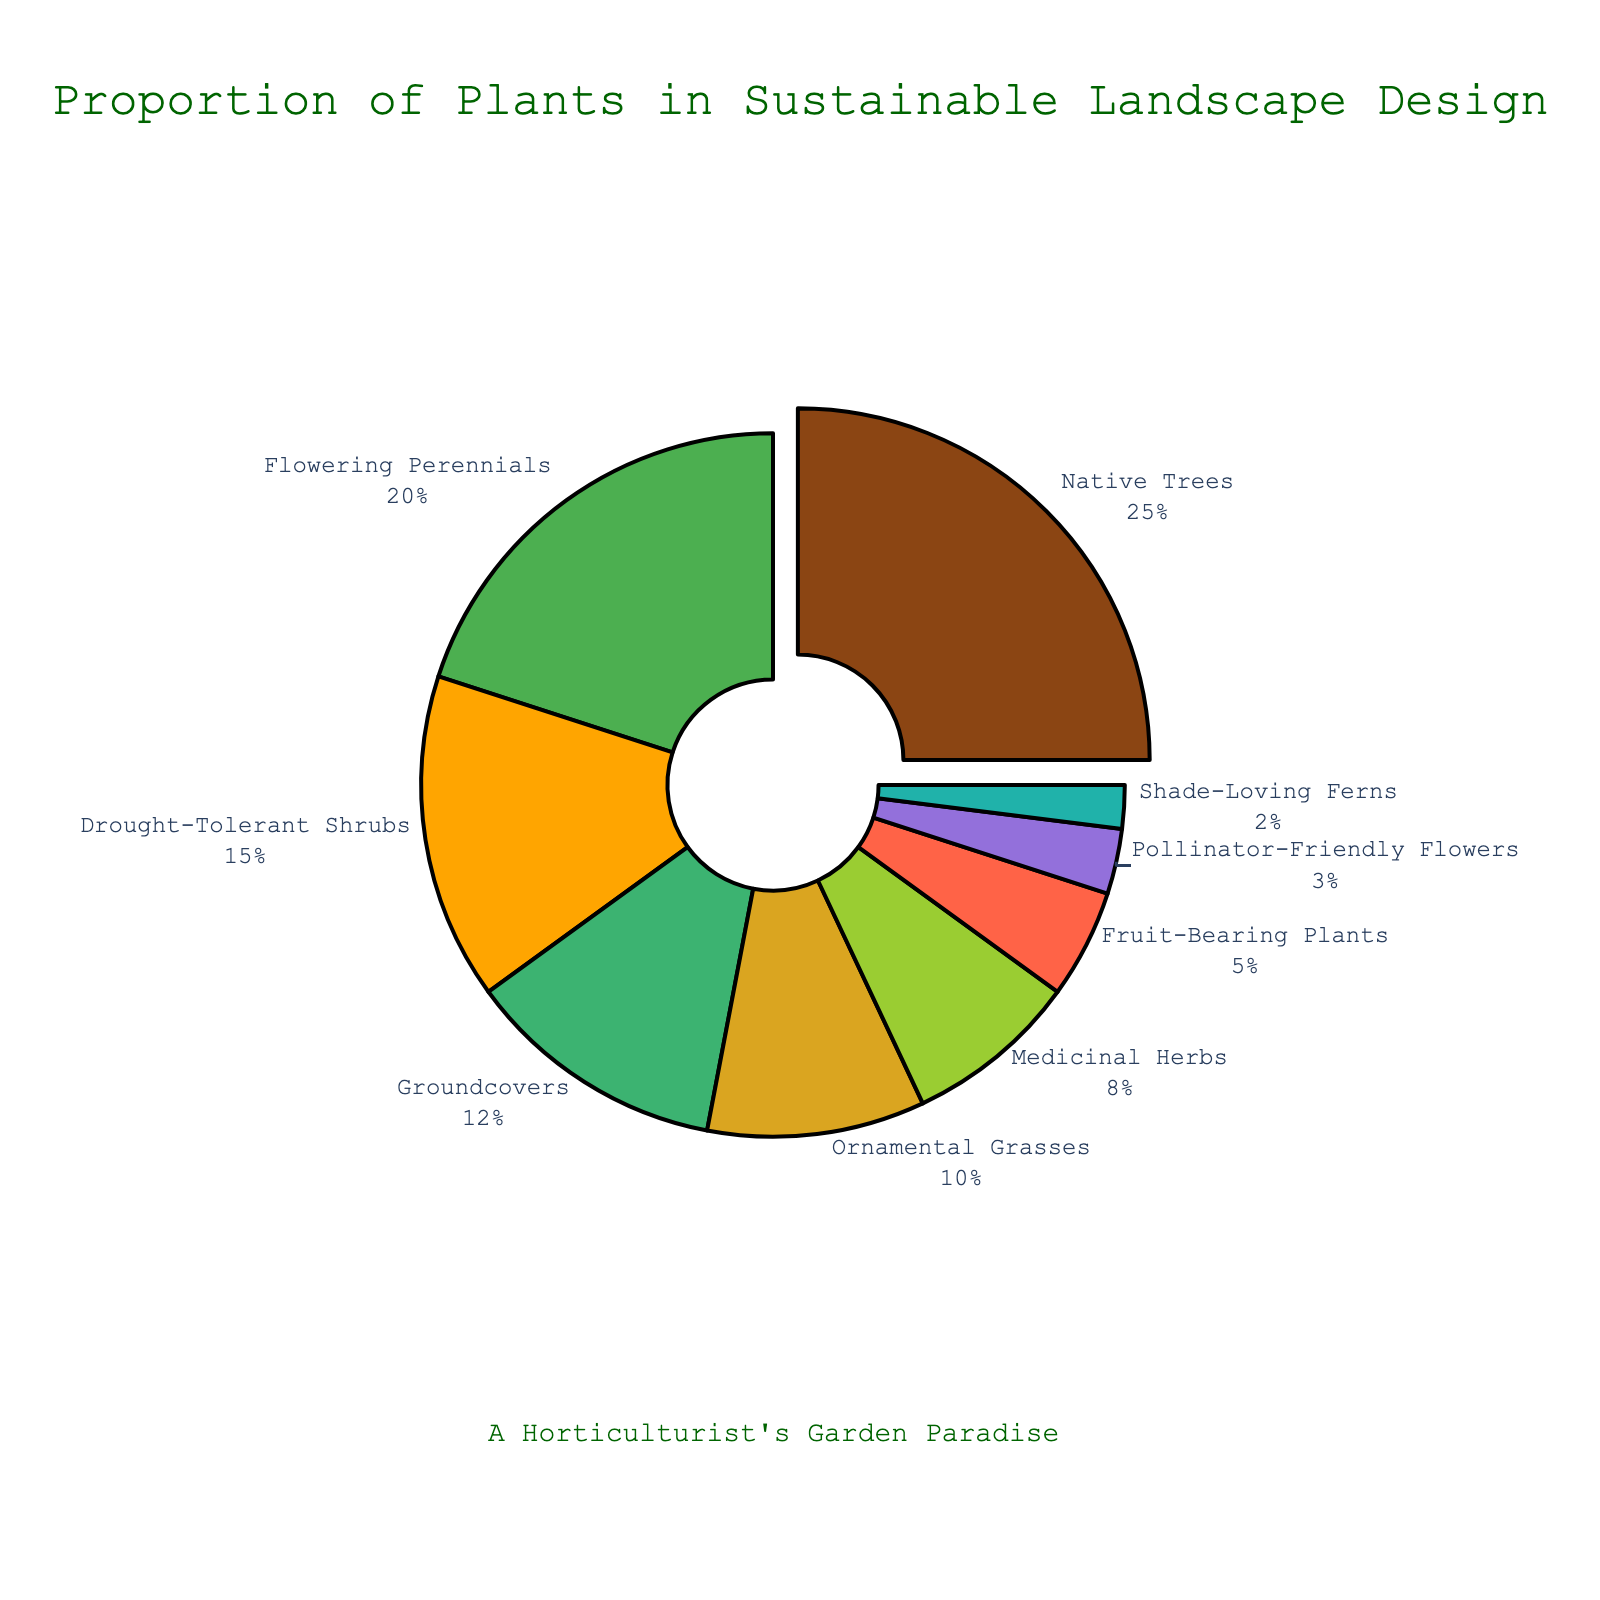Which type of plant has the largest proportion in the sustainable landscape design? The pie chart shows the percentages of different plant types. The Native Trees section is pulled out and labeled with 25%, making it the largest proportion.
Answer: Native Trees What is the combined percentage of Flowering Perennials and Drought-Tolerant Shrubs? To find the combined percentage, add the percentages for Flowering Perennials (20%) and Drought-Tolerant Shrubs (15%). 20% + 15% = 35%.
Answer: 35% Which has a higher proportion, Medicinal Herbs or Fruit-Bearing Plants, and by how much? Compare the percentages: Medicinal Herbs have 8% and Fruit-Bearing Plants have 5%. The difference is 8% - 5% = 3%.
Answer: Medicinal Herbs by 3% What proportion of the landscape is dedicated to plants that attract pollinators if you combine Pollinator-Friendly Flowers and Flowering Perennials? Add the percentages of Pollinator-Friendly Flowers (3%) and Flowering Perennials (20%). 3% + 20% = 23%.
Answer: 23% Which plant type represents the smallest proportion in the design? Examine the plant types and their proportions. Shade-Loving Ferns have the smallest proportion at 2%.
Answer: Shade-Loving Ferns How many plant types make up exactly 10% or more of the landscape design? Identify plant types with 10% or more: Native Trees (25%), Flowering Perennials (20%), Drought-Tolerant Shrubs (15%), Groundcovers (12%), and Ornamental Grasses (10%). There are 5 such types.
Answer: 5 What is the difference in proportion between the plant type with the largest percentage and the one with the smallest? Subtract the smallest percentage (Shade-Loving Ferns, 2%) from the largest percentage (Native Trees, 25%). 25% - 2% = 23%.
Answer: 23% Of the total plant percentages, what percentage represents the sum of the smallest three categories? Add the percentages of the smallest three categories: Pollinator-Friendly Flowers (3%), Shade-Loving Ferns (2%), and Fruit-Bearing Plants (5%). 3% + 2% + 5% = 10%.
Answer: 10% What percentage more are Native Trees than Ornamental Grasses? Subtract the percentage of Ornamental Grasses (10%) from Native Trees (25%). 25% - 10% = 15%.
Answer: 15% Calculate the average percentage for all plant types shown in the chart. There are 9 plant types. Add all the percentages: 25 + 20 + 15 + 12 + 10 + 8 + 5 + 3 + 2 = 100. Divide by the number of plant types: 100 / 9 ≈ 11.11%.
Answer: 11.11% 